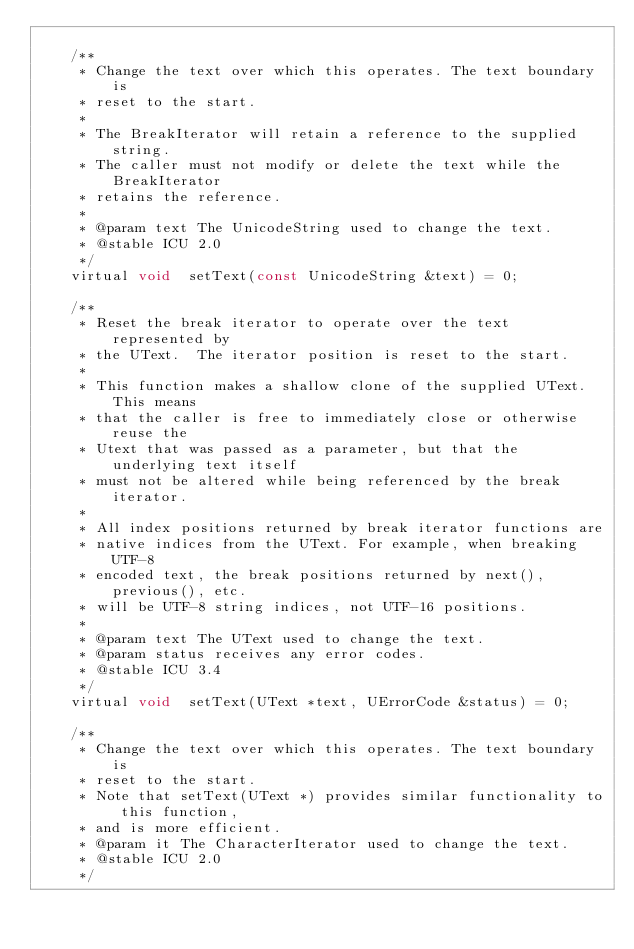<code> <loc_0><loc_0><loc_500><loc_500><_C_>
    /**
     * Change the text over which this operates. The text boundary is
     * reset to the start.
     *
     * The BreakIterator will retain a reference to the supplied string.
     * The caller must not modify or delete the text while the BreakIterator
     * retains the reference.
     *
     * @param text The UnicodeString used to change the text.
     * @stable ICU 2.0
     */
    virtual void  setText(const UnicodeString &text) = 0;

    /**
     * Reset the break iterator to operate over the text represented by
     * the UText.  The iterator position is reset to the start.
     *
     * This function makes a shallow clone of the supplied UText.  This means
     * that the caller is free to immediately close or otherwise reuse the
     * Utext that was passed as a parameter, but that the underlying text itself
     * must not be altered while being referenced by the break iterator.
     *
     * All index positions returned by break iterator functions are
     * native indices from the UText. For example, when breaking UTF-8
     * encoded text, the break positions returned by next(), previous(), etc.
     * will be UTF-8 string indices, not UTF-16 positions.
     *
     * @param text The UText used to change the text.
     * @param status receives any error codes.
     * @stable ICU 3.4
     */
    virtual void  setText(UText *text, UErrorCode &status) = 0;

    /**
     * Change the text over which this operates. The text boundary is
     * reset to the start.
     * Note that setText(UText *) provides similar functionality to this function,
     * and is more efficient.
     * @param it The CharacterIterator used to change the text.
     * @stable ICU 2.0
     */</code> 